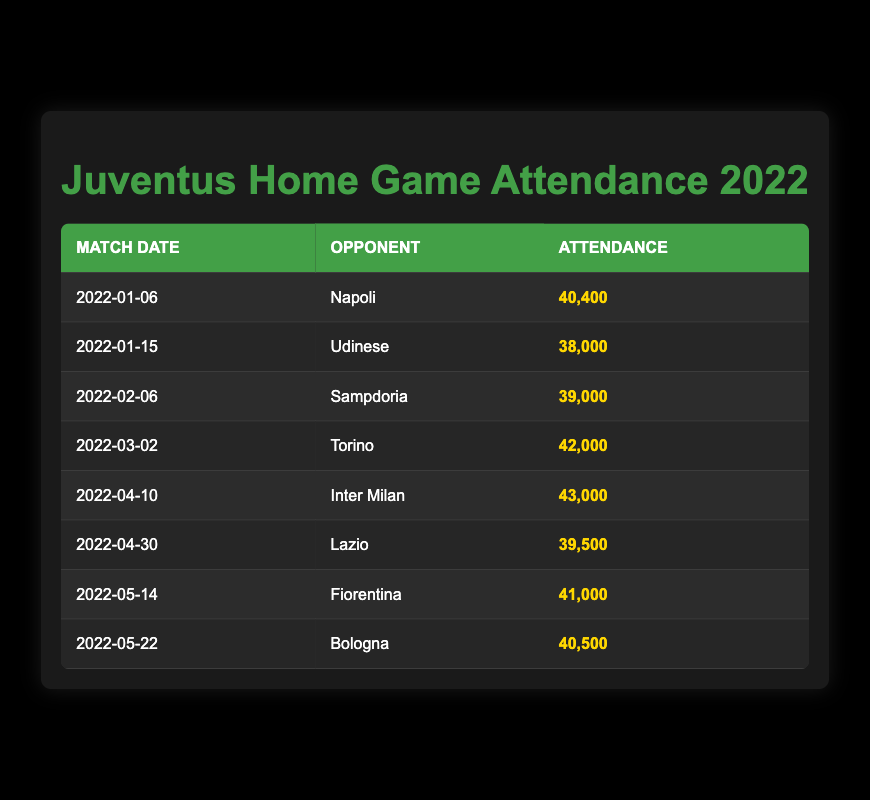What was the highest attendance for a home game in 2022? The highest attendance figure is found by scanning the Attendance column. The highest value is 43,000 for the match against Inter Milan on April 10th.
Answer: 43,000 What was Juventus' attendance for the match against Lazio? The attendance for the match against Lazio on April 30th is listed in the table as 39,500.
Answer: 39,500 How many matches had an attendance of over 40,000? By examining the Attendance column, the matches with over 40,000 attendees are against Napoli (40,400), Torino (42,000), Inter Milan (43,000), Fiorentina (41,000), and Bologna (40,500). This gives a total of 5 matches.
Answer: 5 What is the average attendance for all the home games? To calculate the average, sum all the attendance figures (40400 + 38000 + 39000 + 42000 + 43000 + 39500 + 41000 + 40500 =  318900) and divide by the number of games (8), leading to an average attendance of 39,862.5. Rounding gives us 39,863.
Answer: 39,863 Did Juventus have a match with the least attendance in January? Checking the January matches, the attendance for the Napoli match is 40,400, and for the Udinese match is 38,000. Clearly, Udinese had the least attendance at 38,000.
Answer: Yes Which opponent had the highest attendance for a home game? The opponent with the highest attendance can be determined from the values listed. Inter Milan, with an attendance of 43,000, is the highest.
Answer: Inter Milan What is the difference in attendance between the match against Sampdoria and the match against Bologna? The attendance for Sampdoria is 39,000 and for Bologna is 40,500. The difference can be calculated as 40,500 - 39,000 = 1,500.
Answer: 1,500 How many matches had an attendance lower than 40,000? By looking through the Attendance column, the matches that had attendance lower than 40,000 are against Udinese (38,000) and Sampdoria (39,000), resulting in a total of 2 matches.
Answer: 2 Was there any match with exactly 40,000 attendees? Checking all the attendance values in the table reveals that there was no match with exactly 40,000 attendees.
Answer: No 